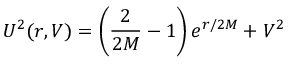Convert formula to latex. <formula><loc_0><loc_0><loc_500><loc_500>U ^ { 2 } ( r , V ) = \left ( \frac { 2 } { 2 M } - 1 \right ) e ^ { r / 2 M } + V ^ { 2 }</formula> 